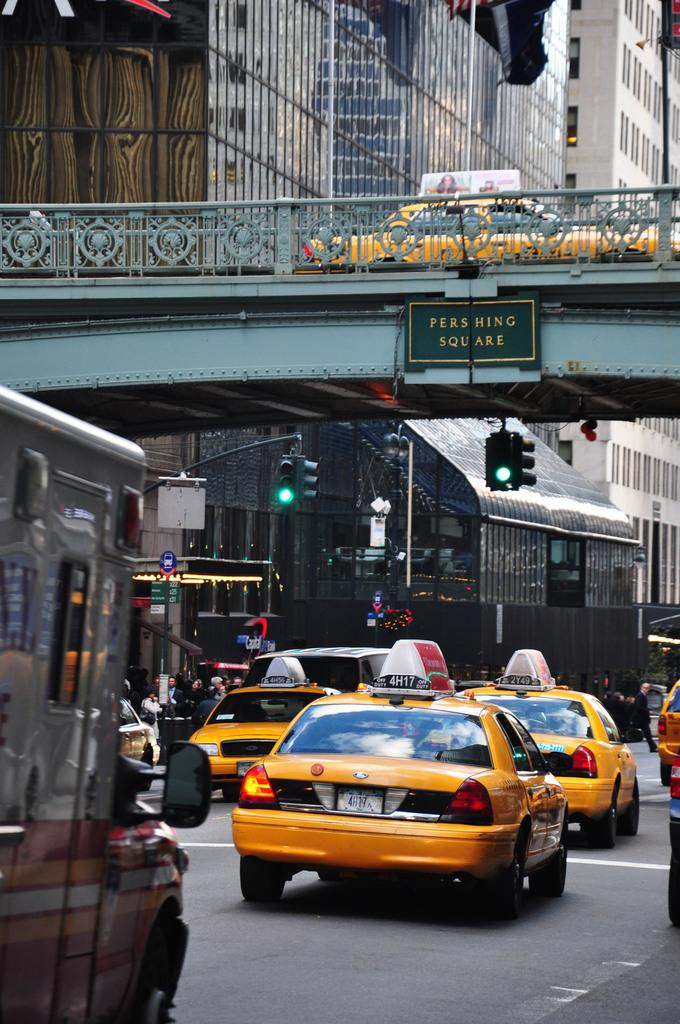<image>
Present a compact description of the photo's key features. Taxi cabs drive under a bridge at Pershing Square. 